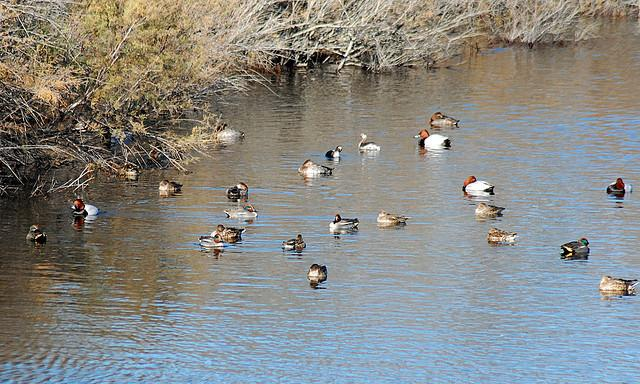What are the males called? drakes 